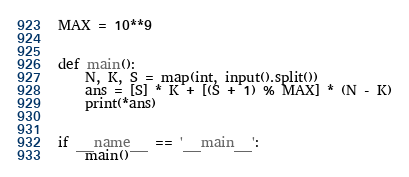<code> <loc_0><loc_0><loc_500><loc_500><_Python_>MAX = 10**9


def main():
    N, K, S = map(int, input().split())
    ans = [S] * K + [(S + 1) % MAX] * (N - K)
    print(*ans)


if __name__ == '__main__':
    main()
</code> 